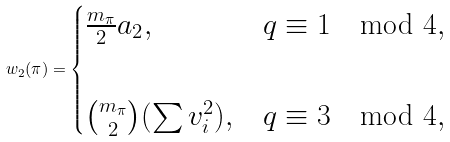<formula> <loc_0><loc_0><loc_500><loc_500>w _ { 2 } ( \pi ) = \begin{cases} \frac { m _ { \pi } } { 2 } a _ { 2 } , & q \equiv 1 \mod 4 , \\ \\ \binom { m _ { \pi } } { 2 } ( \sum v _ { i } ^ { 2 } ) , & q \equiv 3 \mod 4 , \end{cases}</formula> 